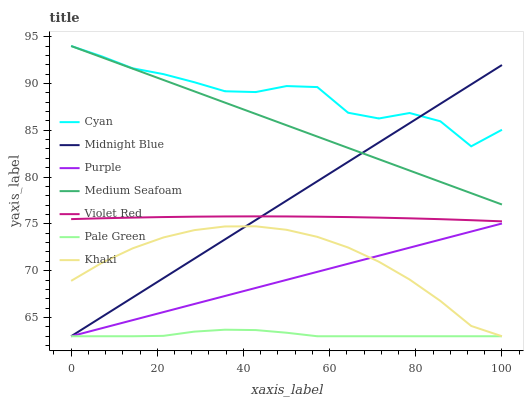Does Pale Green have the minimum area under the curve?
Answer yes or no. Yes. Does Cyan have the maximum area under the curve?
Answer yes or no. Yes. Does Khaki have the minimum area under the curve?
Answer yes or no. No. Does Khaki have the maximum area under the curve?
Answer yes or no. No. Is Medium Seafoam the smoothest?
Answer yes or no. Yes. Is Cyan the roughest?
Answer yes or no. Yes. Is Khaki the smoothest?
Answer yes or no. No. Is Khaki the roughest?
Answer yes or no. No. Does Khaki have the lowest value?
Answer yes or no. Yes. Does Cyan have the lowest value?
Answer yes or no. No. Does Medium Seafoam have the highest value?
Answer yes or no. Yes. Does Khaki have the highest value?
Answer yes or no. No. Is Pale Green less than Medium Seafoam?
Answer yes or no. Yes. Is Violet Red greater than Purple?
Answer yes or no. Yes. Does Midnight Blue intersect Pale Green?
Answer yes or no. Yes. Is Midnight Blue less than Pale Green?
Answer yes or no. No. Is Midnight Blue greater than Pale Green?
Answer yes or no. No. Does Pale Green intersect Medium Seafoam?
Answer yes or no. No. 